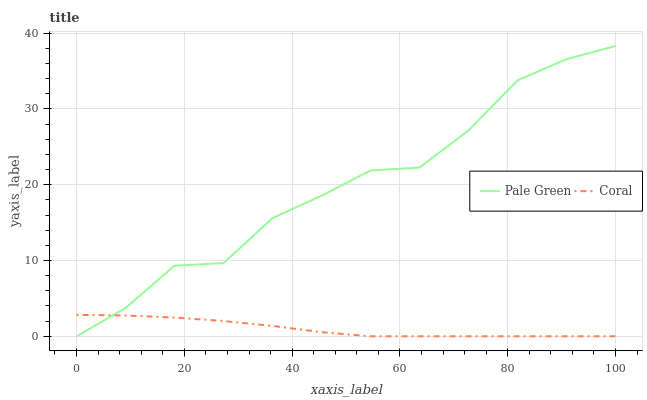Does Coral have the minimum area under the curve?
Answer yes or no. Yes. Does Pale Green have the maximum area under the curve?
Answer yes or no. Yes. Does Pale Green have the minimum area under the curve?
Answer yes or no. No. Is Coral the smoothest?
Answer yes or no. Yes. Is Pale Green the roughest?
Answer yes or no. Yes. Is Pale Green the smoothest?
Answer yes or no. No. Does Pale Green have the highest value?
Answer yes or no. Yes. Does Coral intersect Pale Green?
Answer yes or no. Yes. Is Coral less than Pale Green?
Answer yes or no. No. Is Coral greater than Pale Green?
Answer yes or no. No. 